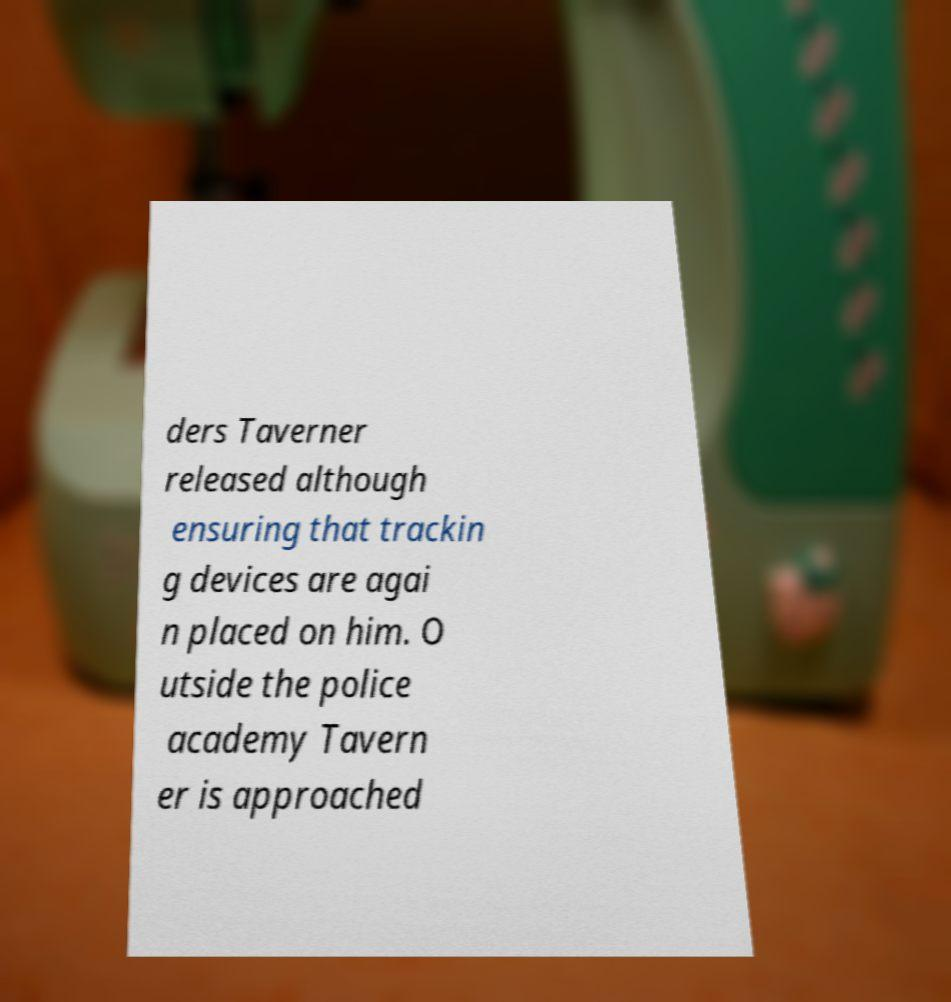Can you read and provide the text displayed in the image?This photo seems to have some interesting text. Can you extract and type it out for me? ders Taverner released although ensuring that trackin g devices are agai n placed on him. O utside the police academy Tavern er is approached 